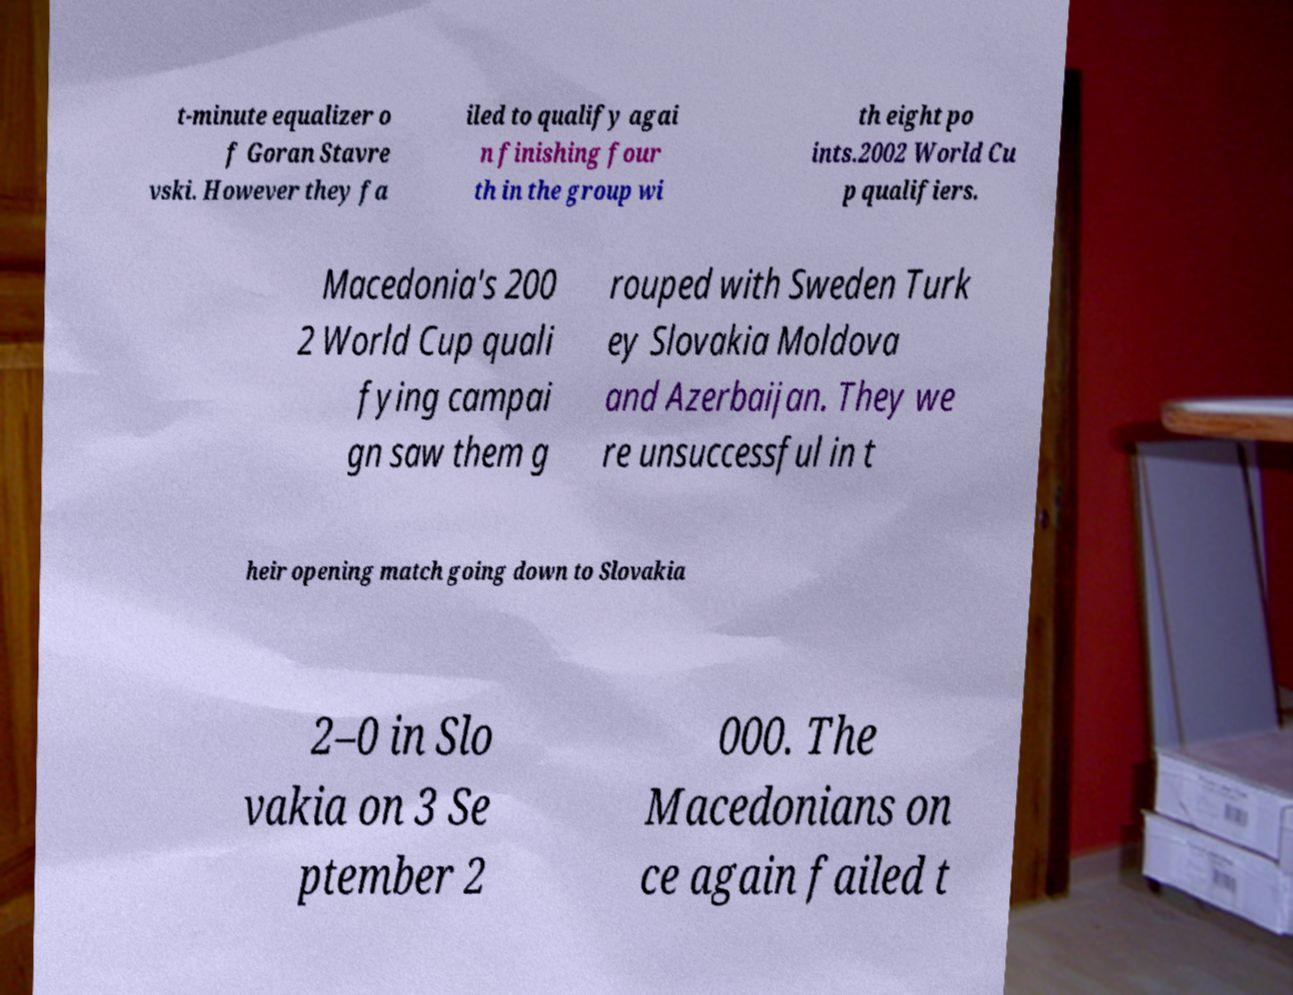Please read and relay the text visible in this image. What does it say? t-minute equalizer o f Goran Stavre vski. However they fa iled to qualify agai n finishing four th in the group wi th eight po ints.2002 World Cu p qualifiers. Macedonia's 200 2 World Cup quali fying campai gn saw them g rouped with Sweden Turk ey Slovakia Moldova and Azerbaijan. They we re unsuccessful in t heir opening match going down to Slovakia 2–0 in Slo vakia on 3 Se ptember 2 000. The Macedonians on ce again failed t 